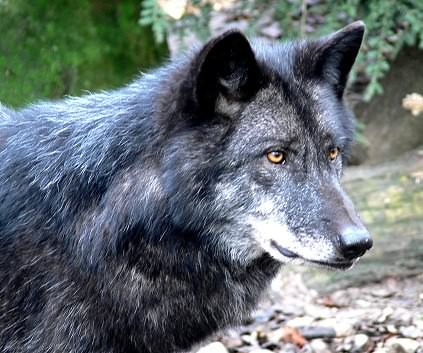In this task, you are given an image from a dataset, which contains images from different categories of animals, objects, and vehicles. These categories further divide into subcategories. Your job is to classify the given image into one of these subcategories, which could be anything from an aeroplane to a zebra. Your classification should be based on key identifiers like size, shape, color, distinctive features, and the context or environment depicted in the image. The animal in the provided image can be classified as a wolf, not merely by its size and the grey-black coloration of its fur, but also by the characteristic intense gaze and the sharp, alert ears positioned amidst a natural forest setting. This combination of features, including the thick fur coat adapted for colder environments, points definitively to the subcategory of a wolf, a distinguished member of the canidae family. 